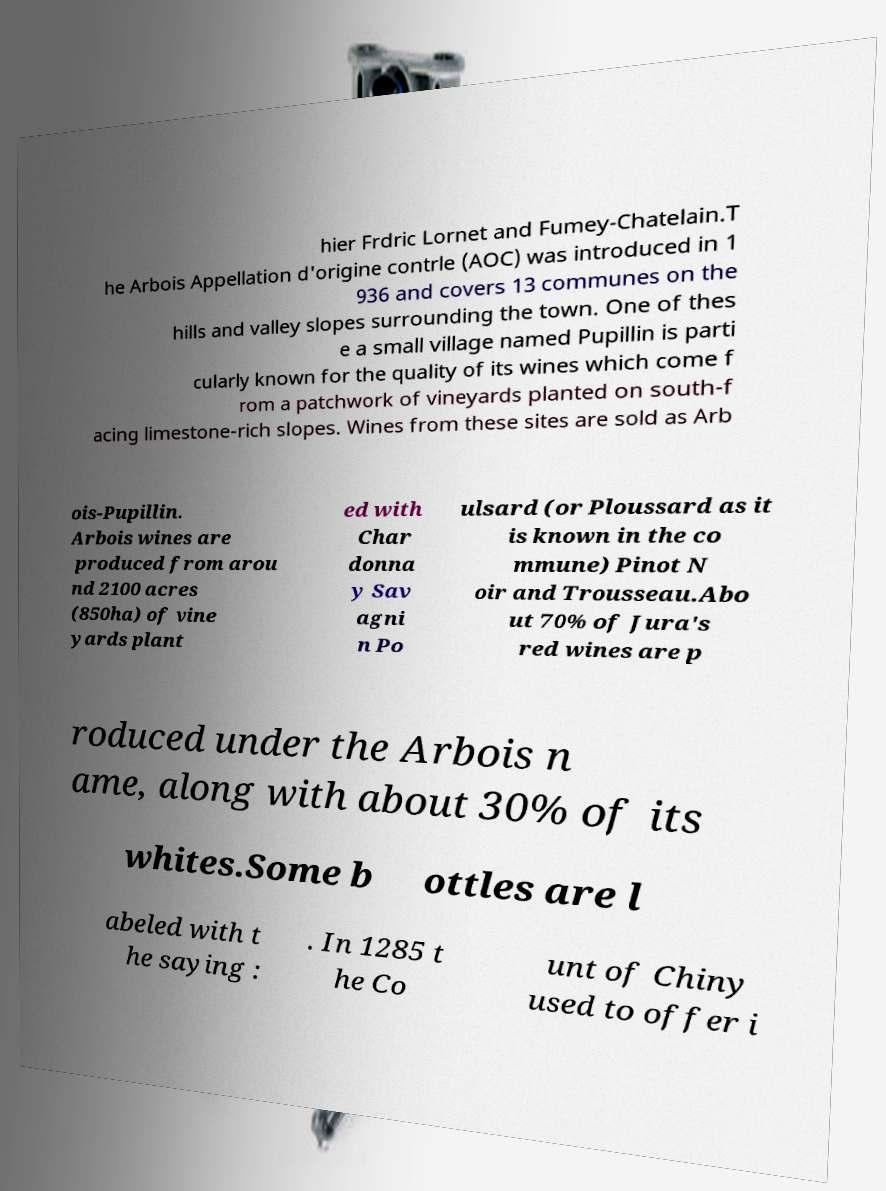Please identify and transcribe the text found in this image. hier Frdric Lornet and Fumey-Chatelain.T he Arbois Appellation d'origine contrle (AOC) was introduced in 1 936 and covers 13 communes on the hills and valley slopes surrounding the town. One of thes e a small village named Pupillin is parti cularly known for the quality of its wines which come f rom a patchwork of vineyards planted on south-f acing limestone-rich slopes. Wines from these sites are sold as Arb ois-Pupillin. Arbois wines are produced from arou nd 2100 acres (850ha) of vine yards plant ed with Char donna y Sav agni n Po ulsard (or Ploussard as it is known in the co mmune) Pinot N oir and Trousseau.Abo ut 70% of Jura's red wines are p roduced under the Arbois n ame, along with about 30% of its whites.Some b ottles are l abeled with t he saying : . In 1285 t he Co unt of Chiny used to offer i 